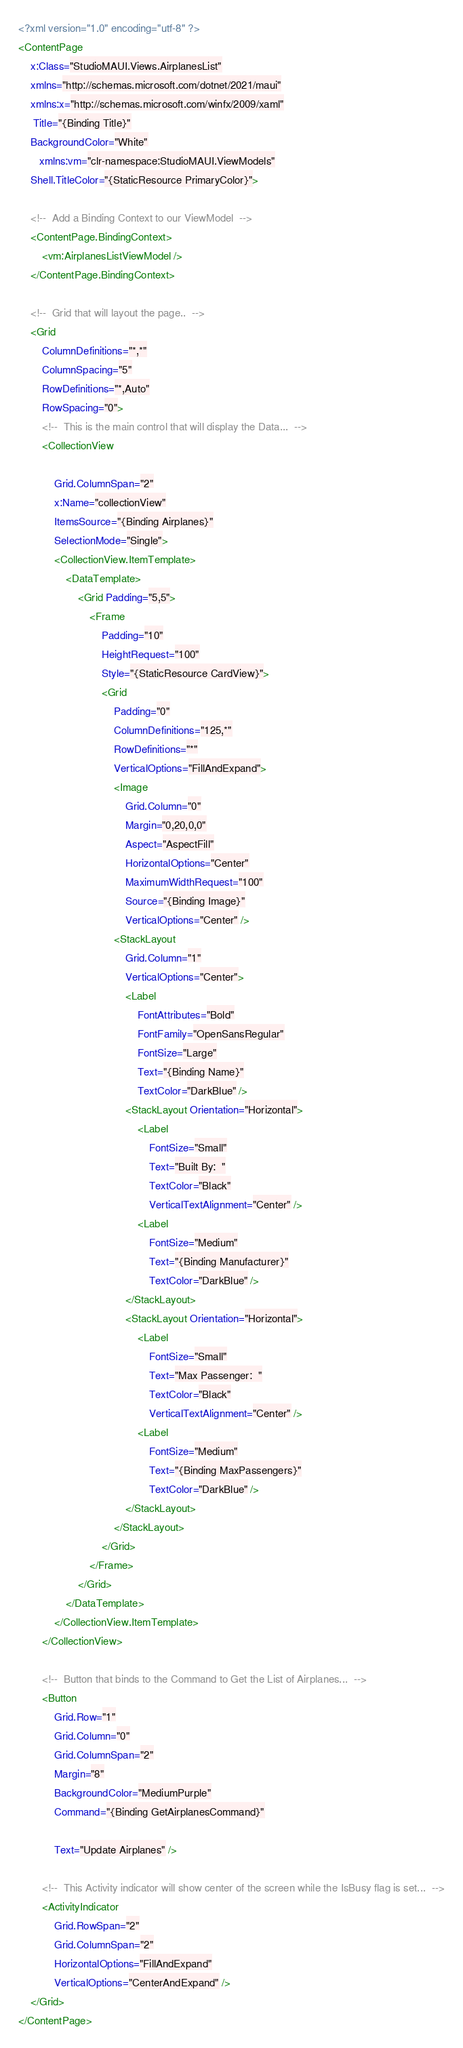<code> <loc_0><loc_0><loc_500><loc_500><_XML_><?xml version="1.0" encoding="utf-8" ?>
<ContentPage
    x:Class="StudioMAUI.Views.AirplanesList"
    xmlns="http://schemas.microsoft.com/dotnet/2021/maui"
    xmlns:x="http://schemas.microsoft.com/winfx/2009/xaml" 
     Title="{Binding Title}"
    BackgroundColor="White"
       xmlns:vm="clr-namespace:StudioMAUI.ViewModels"
    Shell.TitleColor="{StaticResource PrimaryColor}">

    <!--  Add a Binding Context to our ViewModel  -->
    <ContentPage.BindingContext>
        <vm:AirplanesListViewModel />
    </ContentPage.BindingContext>

    <!--  Grid that will layout the page..  -->
    <Grid
        ColumnDefinitions="*,*"
        ColumnSpacing="5"
        RowDefinitions="*,Auto"
        RowSpacing="0">
        <!--  This is the main control that will display the Data...  -->
        <CollectionView 
            
            Grid.ColumnSpan="2" 
            x:Name="collectionView"
            ItemsSource="{Binding Airplanes}"
            SelectionMode="Single">
            <CollectionView.ItemTemplate>
                <DataTemplate>
                    <Grid Padding="5,5">
                        <Frame
                            Padding="10"
                            HeightRequest="100"
                            Style="{StaticResource CardView}">
                            <Grid
                                Padding="0"
                                ColumnDefinitions="125,*"
                                RowDefinitions="*"
                                VerticalOptions="FillAndExpand">
                                <Image
                                    Grid.Column="0"
                                    Margin="0,20,0,0"
                                    Aspect="AspectFill"
                                    HorizontalOptions="Center"
                                    MaximumWidthRequest="100"
                                    Source="{Binding Image}"
                                    VerticalOptions="Center" />
                                <StackLayout
                                    Grid.Column="1"
                                    VerticalOptions="Center">
                                    <Label
                                        FontAttributes="Bold"
                                        FontFamily="OpenSansRegular"
                                        FontSize="Large"
                                        Text="{Binding Name}"
                                        TextColor="DarkBlue" />
                                    <StackLayout Orientation="Horizontal">
                                        <Label
                                            FontSize="Small"
                                            Text="Built By:  "
                                            TextColor="Black"
                                            VerticalTextAlignment="Center" />
                                        <Label
                                            FontSize="Medium"
                                            Text="{Binding Manufacturer}"
                                            TextColor="DarkBlue" />
                                    </StackLayout>
                                    <StackLayout Orientation="Horizontal">
                                        <Label
                                            FontSize="Small"
                                            Text="Max Passenger:  "
                                            TextColor="Black"
                                            VerticalTextAlignment="Center" />
                                        <Label
                                            FontSize="Medium"
                                            Text="{Binding MaxPassengers}"
                                            TextColor="DarkBlue" />
                                    </StackLayout>
                                </StackLayout>
                            </Grid>
                        </Frame>
                    </Grid>
                </DataTemplate>
            </CollectionView.ItemTemplate>
        </CollectionView>

        <!--  Button that binds to the Command to Get the List of Airplanes...  -->
        <Button
            Grid.Row="1"
            Grid.Column="0"
            Grid.ColumnSpan="2"
            Margin="8"
            BackgroundColor="MediumPurple"
            Command="{Binding GetAirplanesCommand}"
            
            Text="Update Airplanes" />

        <!--  This Activity indicator will show center of the screen while the IsBusy flag is set...  -->
        <ActivityIndicator
            Grid.RowSpan="2"
            Grid.ColumnSpan="2"
            HorizontalOptions="FillAndExpand" 
            VerticalOptions="CenterAndExpand" />
    </Grid>
</ContentPage></code> 